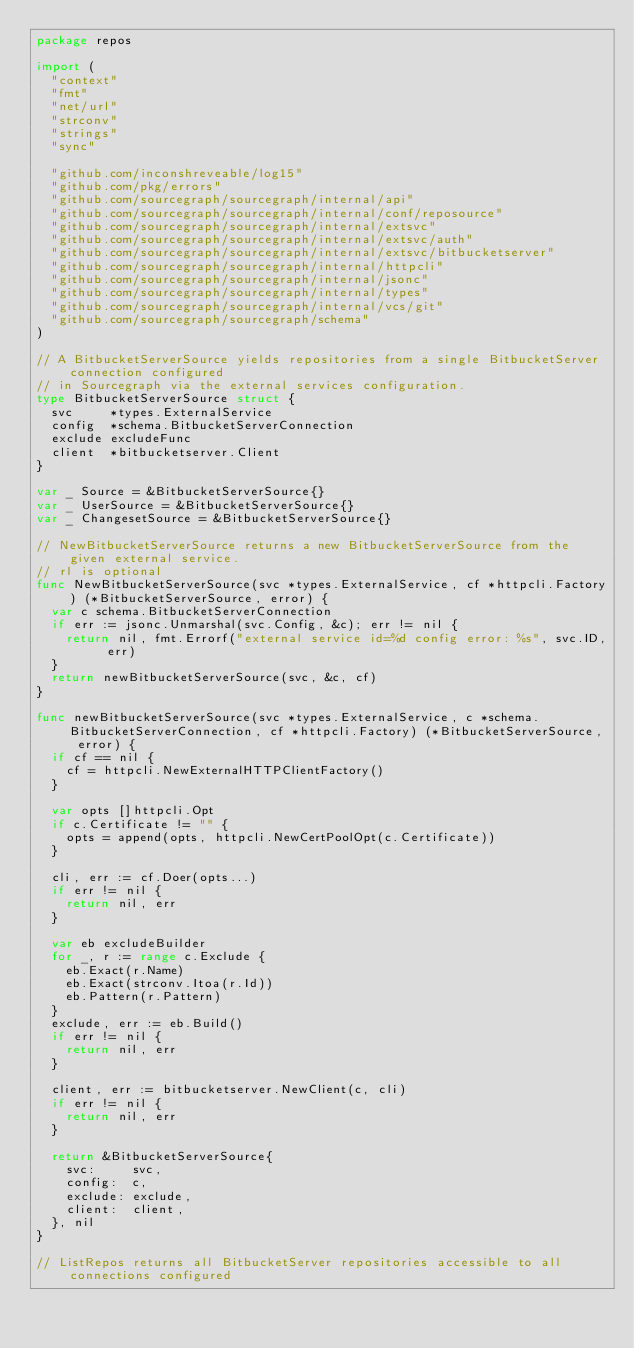Convert code to text. <code><loc_0><loc_0><loc_500><loc_500><_Go_>package repos

import (
	"context"
	"fmt"
	"net/url"
	"strconv"
	"strings"
	"sync"

	"github.com/inconshreveable/log15"
	"github.com/pkg/errors"
	"github.com/sourcegraph/sourcegraph/internal/api"
	"github.com/sourcegraph/sourcegraph/internal/conf/reposource"
	"github.com/sourcegraph/sourcegraph/internal/extsvc"
	"github.com/sourcegraph/sourcegraph/internal/extsvc/auth"
	"github.com/sourcegraph/sourcegraph/internal/extsvc/bitbucketserver"
	"github.com/sourcegraph/sourcegraph/internal/httpcli"
	"github.com/sourcegraph/sourcegraph/internal/jsonc"
	"github.com/sourcegraph/sourcegraph/internal/types"
	"github.com/sourcegraph/sourcegraph/internal/vcs/git"
	"github.com/sourcegraph/sourcegraph/schema"
)

// A BitbucketServerSource yields repositories from a single BitbucketServer connection configured
// in Sourcegraph via the external services configuration.
type BitbucketServerSource struct {
	svc     *types.ExternalService
	config  *schema.BitbucketServerConnection
	exclude excludeFunc
	client  *bitbucketserver.Client
}

var _ Source = &BitbucketServerSource{}
var _ UserSource = &BitbucketServerSource{}
var _ ChangesetSource = &BitbucketServerSource{}

// NewBitbucketServerSource returns a new BitbucketServerSource from the given external service.
// rl is optional
func NewBitbucketServerSource(svc *types.ExternalService, cf *httpcli.Factory) (*BitbucketServerSource, error) {
	var c schema.BitbucketServerConnection
	if err := jsonc.Unmarshal(svc.Config, &c); err != nil {
		return nil, fmt.Errorf("external service id=%d config error: %s", svc.ID, err)
	}
	return newBitbucketServerSource(svc, &c, cf)
}

func newBitbucketServerSource(svc *types.ExternalService, c *schema.BitbucketServerConnection, cf *httpcli.Factory) (*BitbucketServerSource, error) {
	if cf == nil {
		cf = httpcli.NewExternalHTTPClientFactory()
	}

	var opts []httpcli.Opt
	if c.Certificate != "" {
		opts = append(opts, httpcli.NewCertPoolOpt(c.Certificate))
	}

	cli, err := cf.Doer(opts...)
	if err != nil {
		return nil, err
	}

	var eb excludeBuilder
	for _, r := range c.Exclude {
		eb.Exact(r.Name)
		eb.Exact(strconv.Itoa(r.Id))
		eb.Pattern(r.Pattern)
	}
	exclude, err := eb.Build()
	if err != nil {
		return nil, err
	}

	client, err := bitbucketserver.NewClient(c, cli)
	if err != nil {
		return nil, err
	}

	return &BitbucketServerSource{
		svc:     svc,
		config:  c,
		exclude: exclude,
		client:  client,
	}, nil
}

// ListRepos returns all BitbucketServer repositories accessible to all connections configured</code> 